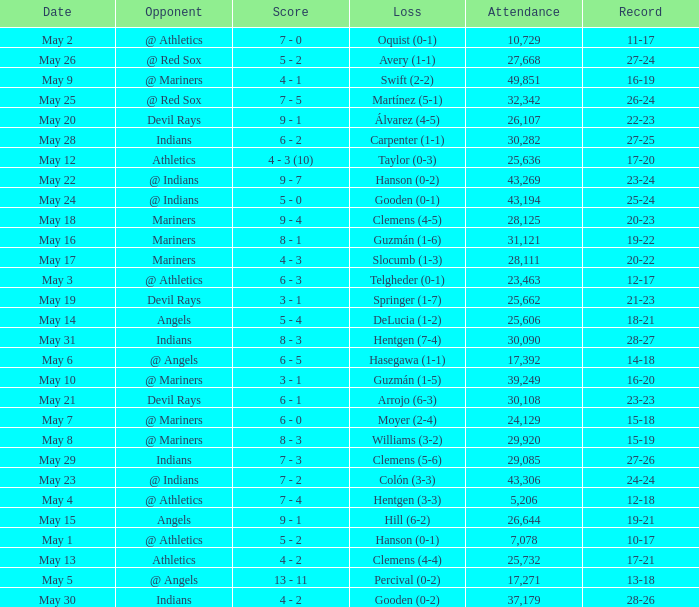For record 25-24, what is the sum of attendance? 1.0. 